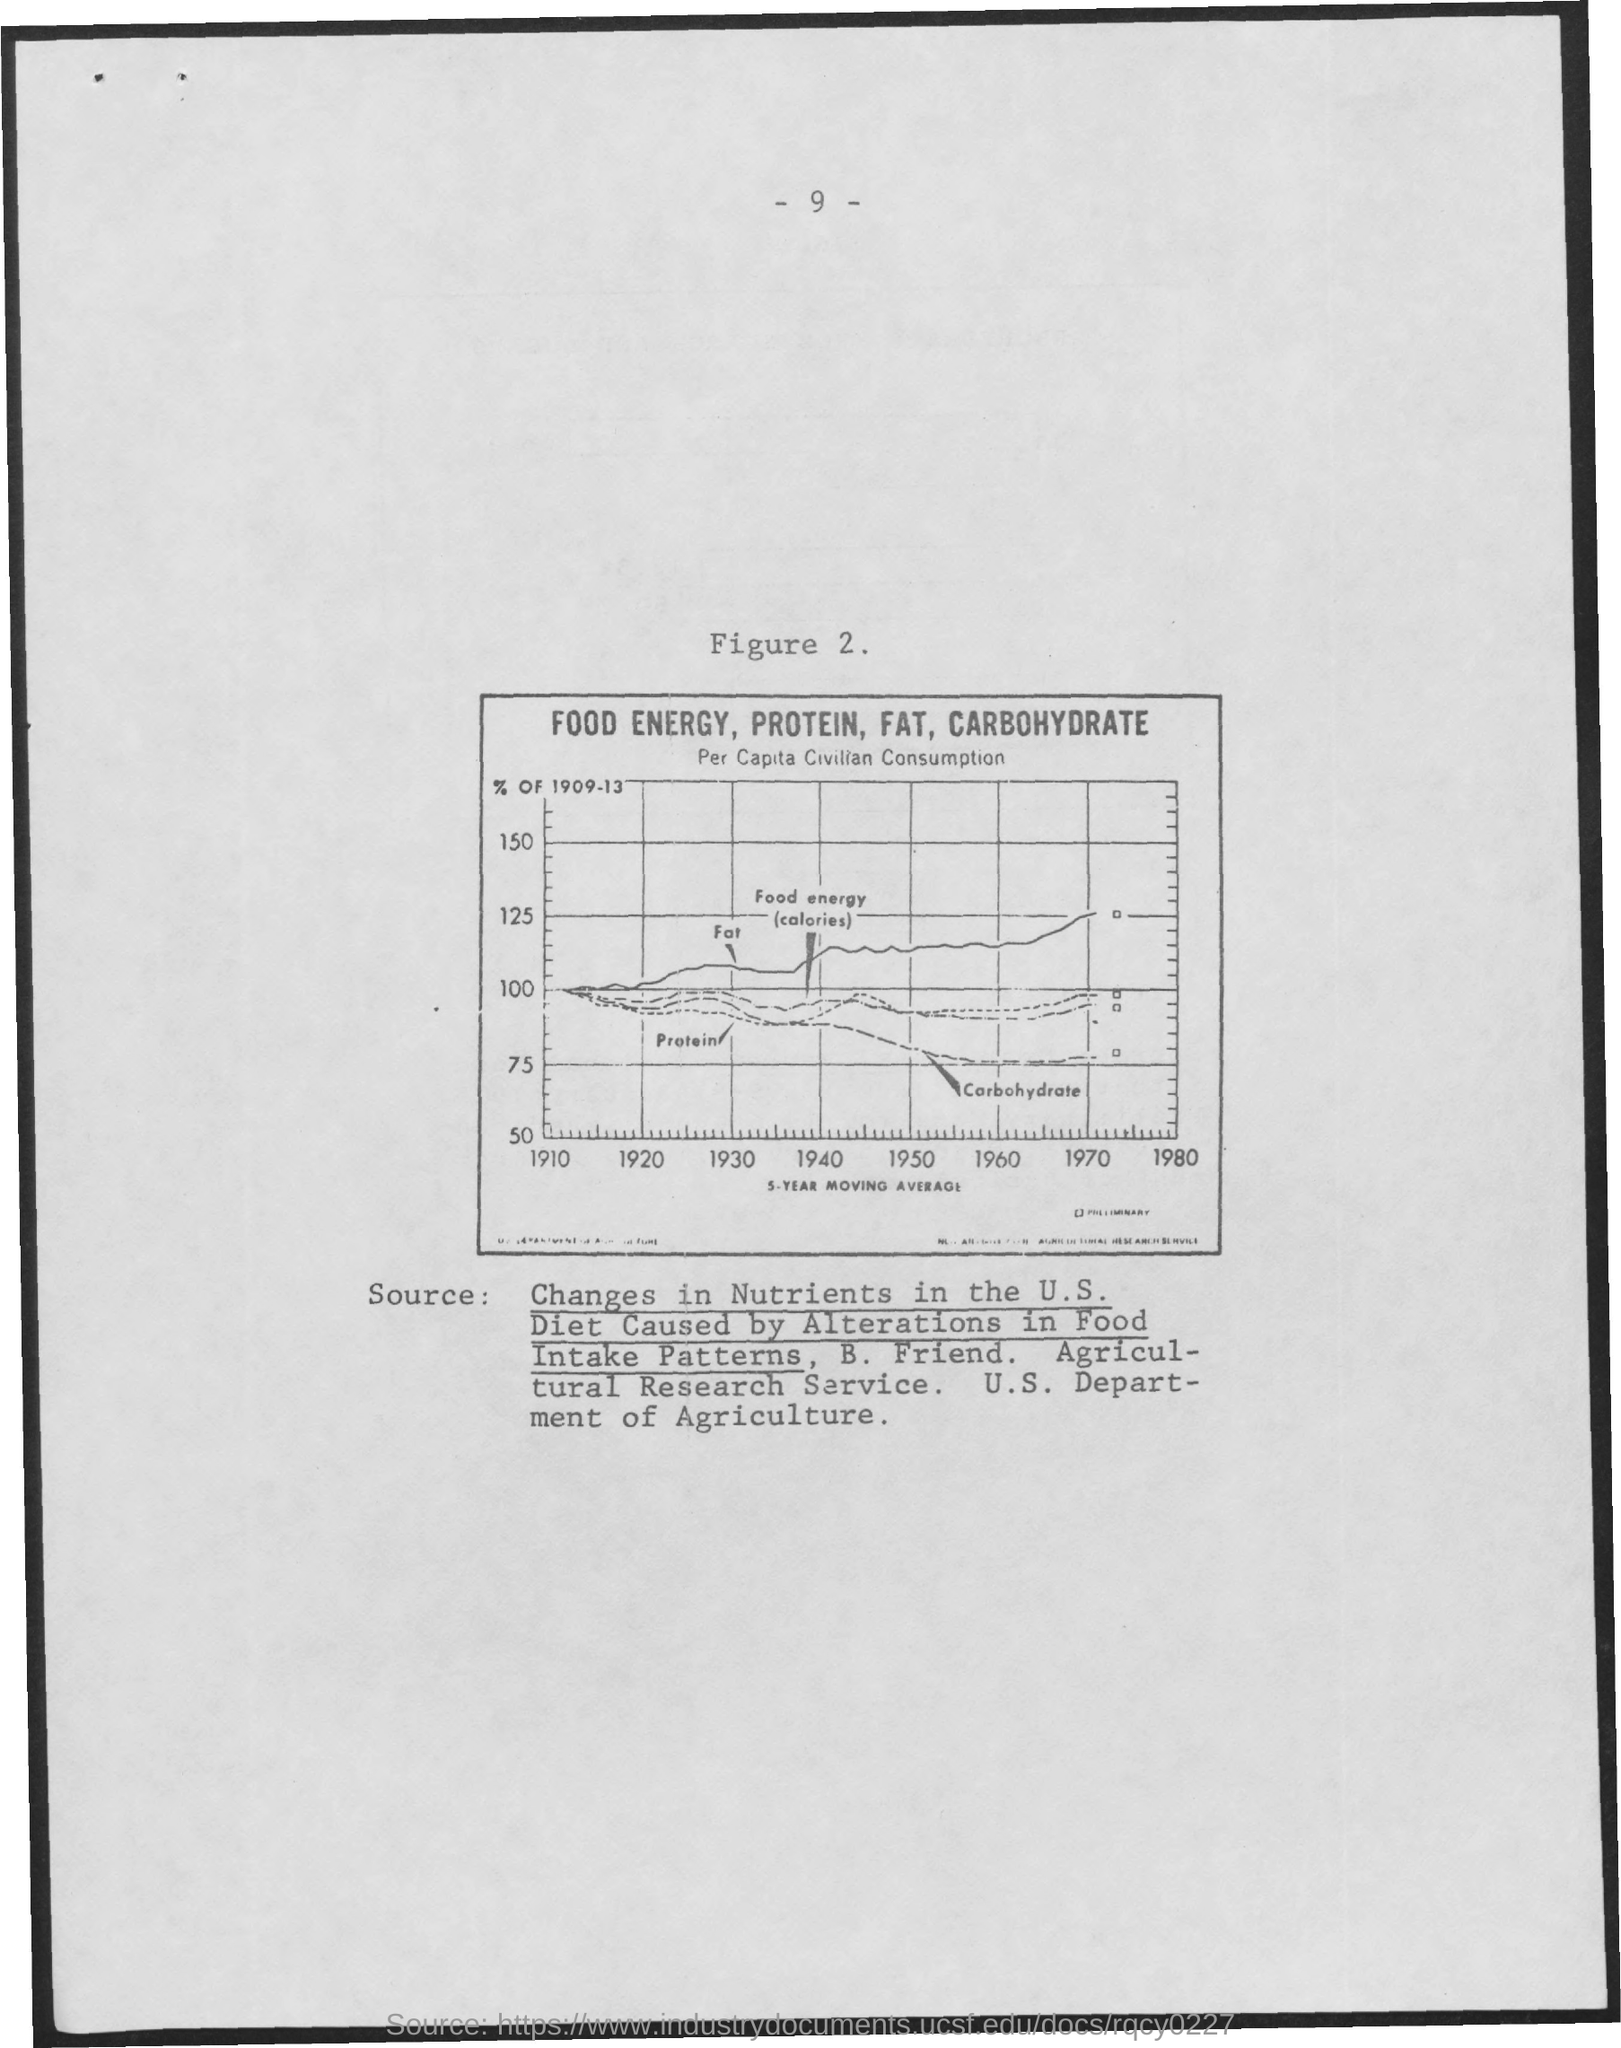What is the Page Number?
Ensure brevity in your answer.  - 9 -. What is the first title inside the box?
Your response must be concise. Food Energy, Protein, Fat, Carbohydrate. What is the second title inside the box?
Offer a very short reply. Per capita civilian consumption. 